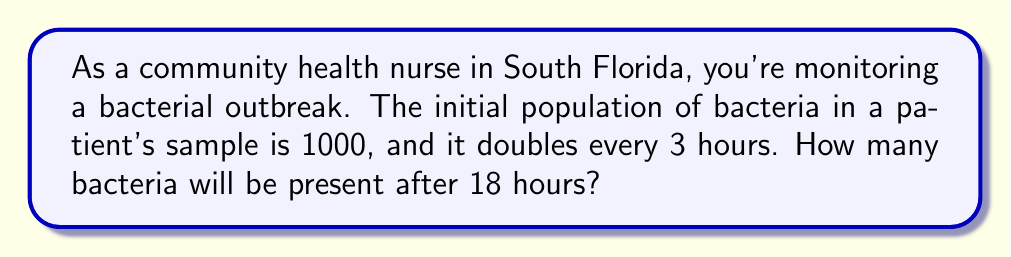Teach me how to tackle this problem. Let's approach this step-by-step:

1) First, we need to identify the key components of exponential growth:
   - Initial population: $P_0 = 1000$
   - Growth factor: 2 (doubles each cycle)
   - Time per cycle: 3 hours
   - Total time: 18 hours

2) We need to determine how many doubling cycles occur in 18 hours:
   $\text{Number of cycles} = \frac{\text{Total time}}{\text{Time per cycle}} = \frac{18}{3} = 6$

3) The exponential growth formula is:
   $P = P_0 \cdot r^n$
   Where:
   $P$ is the final population
   $P_0$ is the initial population
   $r$ is the growth factor
   $n$ is the number of cycles

4) Plugging in our values:
   $P = 1000 \cdot 2^6$

5) Calculate:
   $P = 1000 \cdot 64 = 64,000$

Therefore, after 18 hours, there will be 64,000 bacteria in the sample.
Answer: 64,000 bacteria 